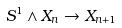Convert formula to latex. <formula><loc_0><loc_0><loc_500><loc_500>S ^ { 1 } \wedge X _ { n } \rightarrow X _ { n + 1 }</formula> 